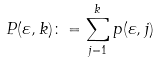Convert formula to latex. <formula><loc_0><loc_0><loc_500><loc_500>P ( \varepsilon , k ) \colon = \sum _ { j = 1 } ^ { k } p ( \varepsilon , j )</formula> 